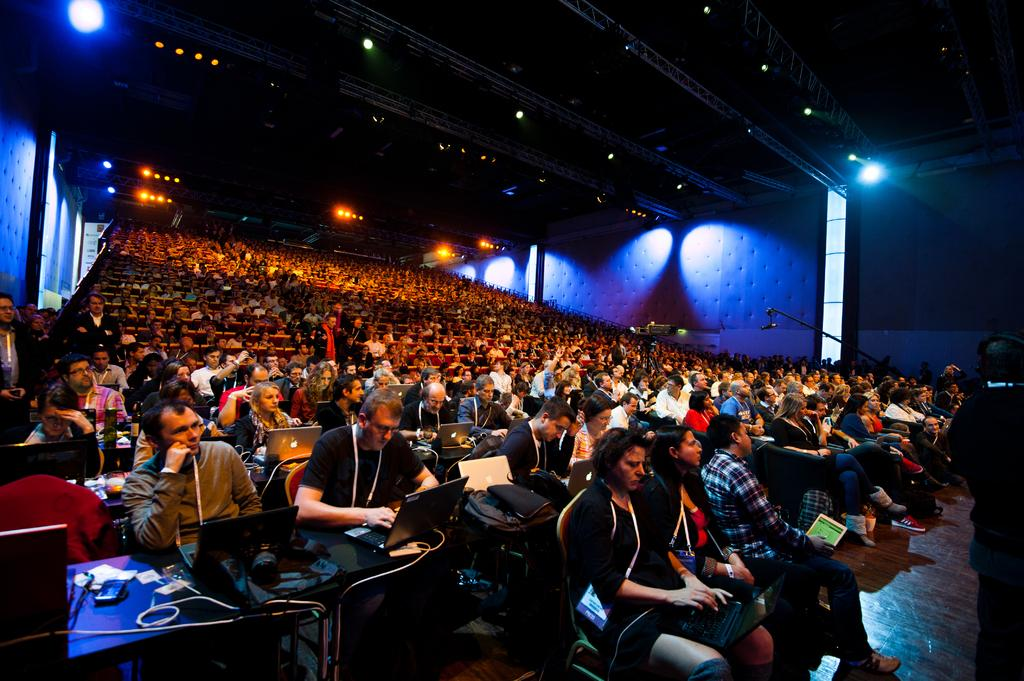What are the people in the image doing? The people in the image are sitting on chairs. What is on the table in the image? There is a table in the image, and laptops and bags are present on it. What color is the straw that the person is using to drink from the laptop? There is no straw present in the image, and the laptops are not associated with drinking. 